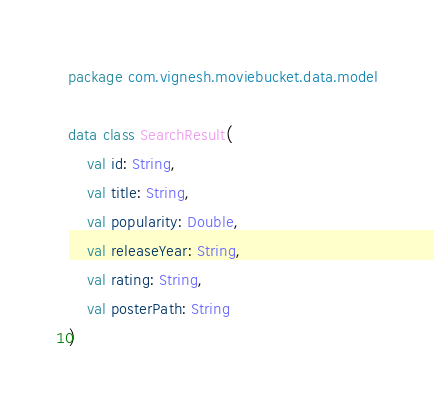<code> <loc_0><loc_0><loc_500><loc_500><_Kotlin_>package com.vignesh.moviebucket.data.model

data class SearchResult(
    val id: String,
    val title: String,
    val popularity: Double,
    val releaseYear: String,
    val rating: String,
    val posterPath: String
)</code> 